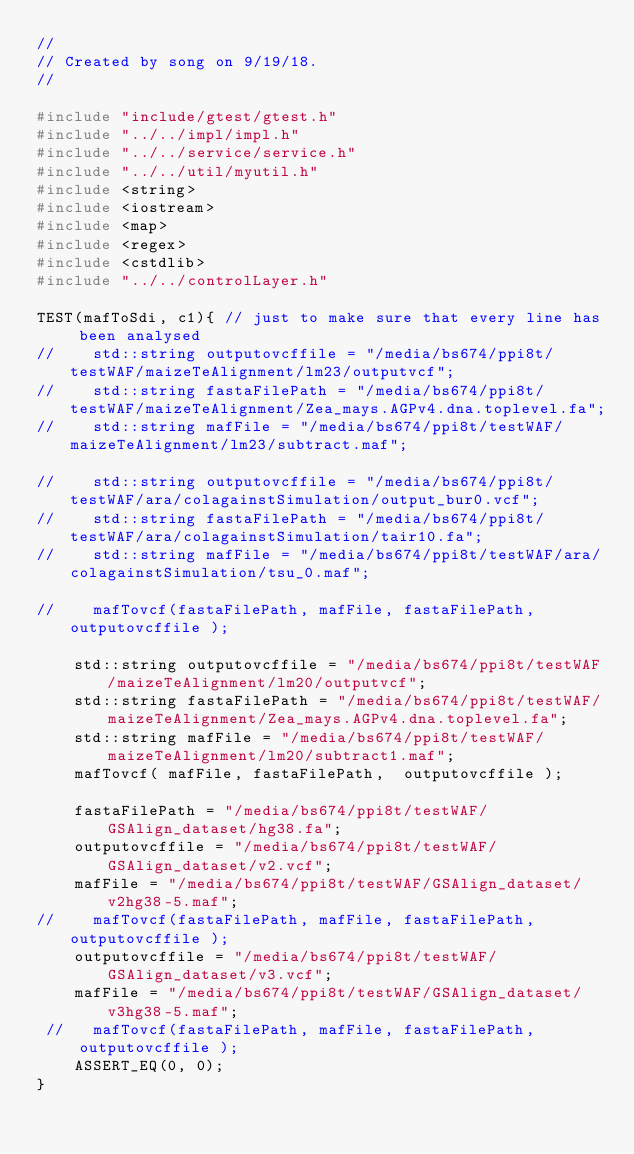Convert code to text. <code><loc_0><loc_0><loc_500><loc_500><_C++_>//
// Created by song on 9/19/18.
//

#include "include/gtest/gtest.h"
#include "../../impl/impl.h"
#include "../../service/service.h"
#include "../../util/myutil.h"
#include <string>
#include <iostream>
#include <map>
#include <regex>
#include <cstdlib>
#include "../../controlLayer.h"

TEST(mafToSdi, c1){ // just to make sure that every line has been analysed
//    std::string outputovcffile = "/media/bs674/ppi8t/testWAF/maizeTeAlignment/lm23/outputvcf";
//    std::string fastaFilePath = "/media/bs674/ppi8t/testWAF/maizeTeAlignment/Zea_mays.AGPv4.dna.toplevel.fa";
//    std::string mafFile = "/media/bs674/ppi8t/testWAF/maizeTeAlignment/lm23/subtract.maf";

//    std::string outputovcffile = "/media/bs674/ppi8t/testWAF/ara/colagainstSimulation/output_bur0.vcf";
//    std::string fastaFilePath = "/media/bs674/ppi8t/testWAF/ara/colagainstSimulation/tair10.fa";
//    std::string mafFile = "/media/bs674/ppi8t/testWAF/ara/colagainstSimulation/tsu_0.maf";

//    mafTovcf(fastaFilePath, mafFile, fastaFilePath,  outputovcffile );

    std::string outputovcffile = "/media/bs674/ppi8t/testWAF/maizeTeAlignment/lm20/outputvcf";
    std::string fastaFilePath = "/media/bs674/ppi8t/testWAF/maizeTeAlignment/Zea_mays.AGPv4.dna.toplevel.fa";
    std::string mafFile = "/media/bs674/ppi8t/testWAF/maizeTeAlignment/lm20/subtract1.maf";
    mafTovcf( mafFile, fastaFilePath,  outputovcffile );

    fastaFilePath = "/media/bs674/ppi8t/testWAF/GSAlign_dataset/hg38.fa";
    outputovcffile = "/media/bs674/ppi8t/testWAF/GSAlign_dataset/v2.vcf";
    mafFile = "/media/bs674/ppi8t/testWAF/GSAlign_dataset/v2hg38-5.maf";
//    mafTovcf(fastaFilePath, mafFile, fastaFilePath,  outputovcffile );
    outputovcffile = "/media/bs674/ppi8t/testWAF/GSAlign_dataset/v3.vcf";
    mafFile = "/media/bs674/ppi8t/testWAF/GSAlign_dataset/v3hg38-5.maf";
 //   mafTovcf(fastaFilePath, mafFile, fastaFilePath,  outputovcffile );
    ASSERT_EQ(0, 0);
}
</code> 